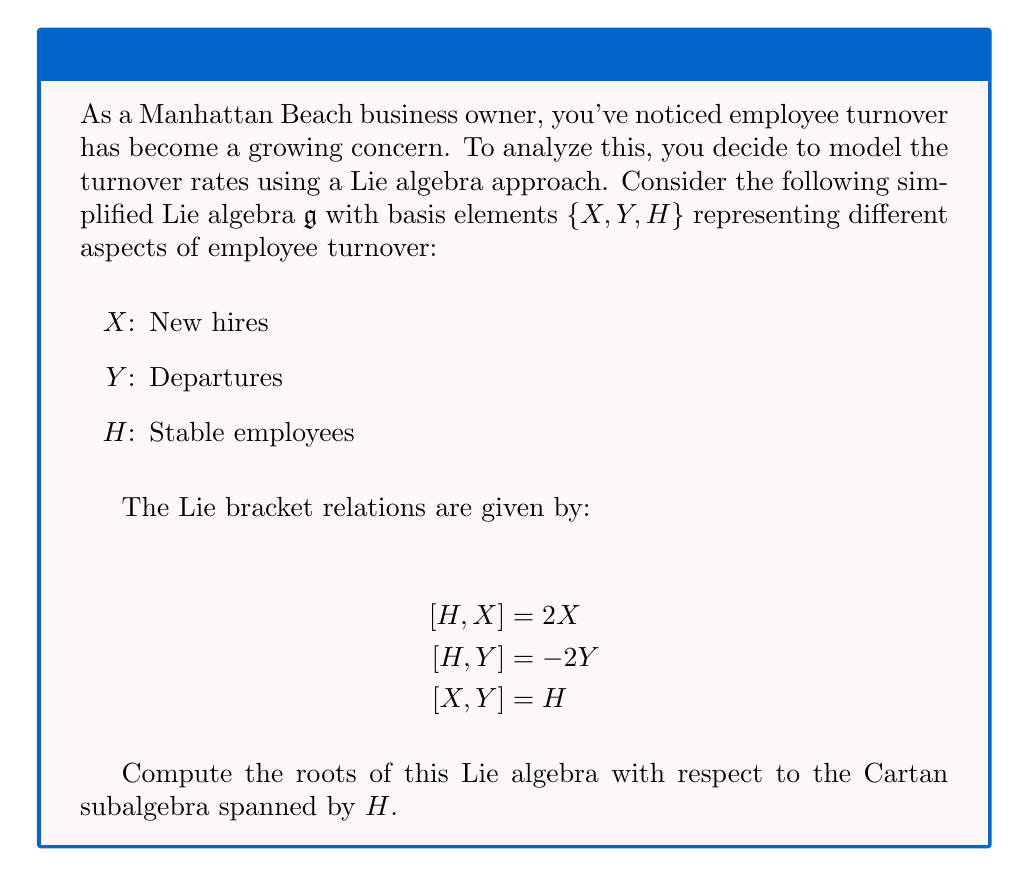Could you help me with this problem? To find the roots of this Lie algebra, we need to follow these steps:

1) First, identify the Cartan subalgebra. In this case, it's already given as the subspace spanned by $H$.

2) Next, we need to find the eigenvalues of $ad_H$ acting on the entire algebra. Recall that for any element $Z$ in the algebra, $ad_H(Z) = [H, Z]$.

3) Let's compute $ad_H$ for each basis element:

   For $X$: $ad_H(X) = [H, X] = 2X$
   For $Y$: $ad_H(Y) = [H, Y] = -2Y$
   For $H$: $ad_H(H) = [H, H] = 0$

4) The eigenvalues of $ad_H$ are the roots of the Lie algebra. From step 3, we can see that:

   $X$ is an eigenvector with eigenvalue 2
   $Y$ is an eigenvector with eigenvalue -2
   $H$ is an eigenvector with eigenvalue 0

5) Therefore, the roots of this Lie algebra are:

   $\alpha = 2$ (corresponding to $X$)
   $\beta = -2$ (corresponding to $Y$)

   Note that 0 is not considered a root.

6) In the root system notation, we typically denote the positive root as $\alpha$ and the negative root as $-\alpha$. So we can write our roots as $\{\alpha, -\alpha\}$ where $\alpha = 2$.

This Lie algebra is isomorphic to $\mathfrak{sl}(2, \mathbb{C})$, which is the simplest non-abelian Lie algebra.
Answer: $\{\alpha, -\alpha\}$ where $\alpha = 2$ 